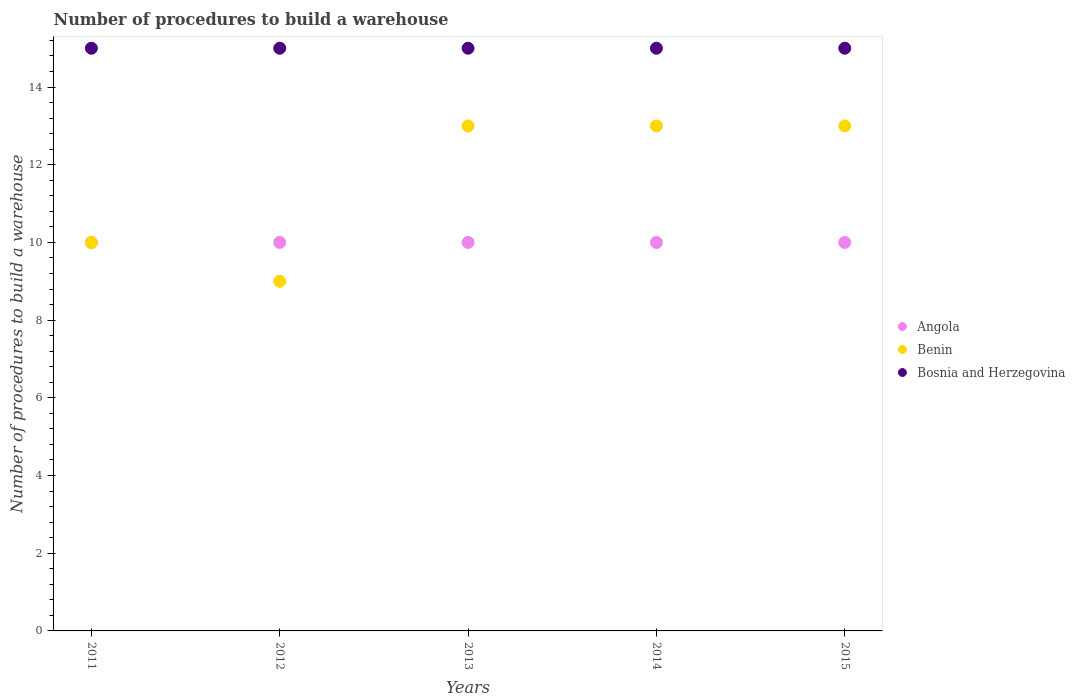How many different coloured dotlines are there?
Offer a very short reply. 3. Is the number of dotlines equal to the number of legend labels?
Provide a short and direct response. Yes. What is the number of procedures to build a warehouse in in Benin in 2011?
Your answer should be compact. 10. Across all years, what is the maximum number of procedures to build a warehouse in in Bosnia and Herzegovina?
Offer a very short reply. 15. Across all years, what is the minimum number of procedures to build a warehouse in in Angola?
Keep it short and to the point. 10. In which year was the number of procedures to build a warehouse in in Benin maximum?
Ensure brevity in your answer.  2013. In which year was the number of procedures to build a warehouse in in Bosnia and Herzegovina minimum?
Offer a very short reply. 2011. What is the total number of procedures to build a warehouse in in Angola in the graph?
Provide a short and direct response. 50. What is the difference between the number of procedures to build a warehouse in in Bosnia and Herzegovina in 2011 and that in 2013?
Your answer should be very brief. 0. What is the difference between the number of procedures to build a warehouse in in Bosnia and Herzegovina in 2013 and the number of procedures to build a warehouse in in Angola in 2014?
Make the answer very short. 5. What is the average number of procedures to build a warehouse in in Angola per year?
Offer a very short reply. 10. In the year 2012, what is the difference between the number of procedures to build a warehouse in in Angola and number of procedures to build a warehouse in in Benin?
Offer a terse response. 1. In how many years, is the number of procedures to build a warehouse in in Bosnia and Herzegovina greater than 12.8?
Keep it short and to the point. 5. What is the difference between the highest and the second highest number of procedures to build a warehouse in in Bosnia and Herzegovina?
Provide a succinct answer. 0. Is it the case that in every year, the sum of the number of procedures to build a warehouse in in Bosnia and Herzegovina and number of procedures to build a warehouse in in Benin  is greater than the number of procedures to build a warehouse in in Angola?
Your answer should be very brief. Yes. Is the number of procedures to build a warehouse in in Angola strictly greater than the number of procedures to build a warehouse in in Benin over the years?
Ensure brevity in your answer.  No. Is the number of procedures to build a warehouse in in Benin strictly less than the number of procedures to build a warehouse in in Bosnia and Herzegovina over the years?
Give a very brief answer. Yes. How many dotlines are there?
Provide a short and direct response. 3. How many years are there in the graph?
Offer a terse response. 5. Are the values on the major ticks of Y-axis written in scientific E-notation?
Give a very brief answer. No. How are the legend labels stacked?
Your response must be concise. Vertical. What is the title of the graph?
Your answer should be compact. Number of procedures to build a warehouse. What is the label or title of the Y-axis?
Provide a short and direct response. Number of procedures to build a warehouse. What is the Number of procedures to build a warehouse of Benin in 2011?
Offer a very short reply. 10. What is the Number of procedures to build a warehouse in Angola in 2013?
Offer a terse response. 10. What is the Number of procedures to build a warehouse of Benin in 2013?
Your response must be concise. 13. What is the Number of procedures to build a warehouse in Angola in 2014?
Your answer should be very brief. 10. What is the Number of procedures to build a warehouse in Bosnia and Herzegovina in 2014?
Provide a succinct answer. 15. What is the Number of procedures to build a warehouse in Benin in 2015?
Your response must be concise. 13. What is the Number of procedures to build a warehouse in Bosnia and Herzegovina in 2015?
Your answer should be compact. 15. Across all years, what is the maximum Number of procedures to build a warehouse in Angola?
Your answer should be compact. 10. What is the total Number of procedures to build a warehouse in Angola in the graph?
Your answer should be very brief. 50. What is the total Number of procedures to build a warehouse in Benin in the graph?
Provide a succinct answer. 58. What is the total Number of procedures to build a warehouse of Bosnia and Herzegovina in the graph?
Keep it short and to the point. 75. What is the difference between the Number of procedures to build a warehouse of Angola in 2011 and that in 2013?
Provide a short and direct response. 0. What is the difference between the Number of procedures to build a warehouse in Benin in 2011 and that in 2013?
Ensure brevity in your answer.  -3. What is the difference between the Number of procedures to build a warehouse of Bosnia and Herzegovina in 2011 and that in 2013?
Provide a short and direct response. 0. What is the difference between the Number of procedures to build a warehouse of Angola in 2011 and that in 2014?
Offer a terse response. 0. What is the difference between the Number of procedures to build a warehouse of Benin in 2011 and that in 2014?
Give a very brief answer. -3. What is the difference between the Number of procedures to build a warehouse in Bosnia and Herzegovina in 2011 and that in 2014?
Keep it short and to the point. 0. What is the difference between the Number of procedures to build a warehouse in Angola in 2011 and that in 2015?
Provide a short and direct response. 0. What is the difference between the Number of procedures to build a warehouse in Angola in 2012 and that in 2014?
Provide a succinct answer. 0. What is the difference between the Number of procedures to build a warehouse in Benin in 2012 and that in 2014?
Provide a succinct answer. -4. What is the difference between the Number of procedures to build a warehouse of Bosnia and Herzegovina in 2012 and that in 2015?
Ensure brevity in your answer.  0. What is the difference between the Number of procedures to build a warehouse in Bosnia and Herzegovina in 2013 and that in 2014?
Make the answer very short. 0. What is the difference between the Number of procedures to build a warehouse of Angola in 2013 and that in 2015?
Make the answer very short. 0. What is the difference between the Number of procedures to build a warehouse of Bosnia and Herzegovina in 2013 and that in 2015?
Give a very brief answer. 0. What is the difference between the Number of procedures to build a warehouse of Angola in 2014 and that in 2015?
Provide a short and direct response. 0. What is the difference between the Number of procedures to build a warehouse in Benin in 2014 and that in 2015?
Your response must be concise. 0. What is the difference between the Number of procedures to build a warehouse in Angola in 2011 and the Number of procedures to build a warehouse in Benin in 2012?
Your response must be concise. 1. What is the difference between the Number of procedures to build a warehouse of Angola in 2011 and the Number of procedures to build a warehouse of Benin in 2014?
Your response must be concise. -3. What is the difference between the Number of procedures to build a warehouse in Angola in 2011 and the Number of procedures to build a warehouse in Bosnia and Herzegovina in 2014?
Your answer should be very brief. -5. What is the difference between the Number of procedures to build a warehouse in Benin in 2011 and the Number of procedures to build a warehouse in Bosnia and Herzegovina in 2014?
Your response must be concise. -5. What is the difference between the Number of procedures to build a warehouse in Benin in 2011 and the Number of procedures to build a warehouse in Bosnia and Herzegovina in 2015?
Keep it short and to the point. -5. What is the difference between the Number of procedures to build a warehouse in Benin in 2012 and the Number of procedures to build a warehouse in Bosnia and Herzegovina in 2013?
Provide a succinct answer. -6. What is the difference between the Number of procedures to build a warehouse of Angola in 2012 and the Number of procedures to build a warehouse of Benin in 2014?
Give a very brief answer. -3. What is the difference between the Number of procedures to build a warehouse in Angola in 2012 and the Number of procedures to build a warehouse in Benin in 2015?
Give a very brief answer. -3. What is the difference between the Number of procedures to build a warehouse in Benin in 2012 and the Number of procedures to build a warehouse in Bosnia and Herzegovina in 2015?
Make the answer very short. -6. What is the difference between the Number of procedures to build a warehouse in Angola in 2013 and the Number of procedures to build a warehouse in Benin in 2014?
Provide a succinct answer. -3. What is the difference between the Number of procedures to build a warehouse of Angola in 2013 and the Number of procedures to build a warehouse of Bosnia and Herzegovina in 2014?
Offer a very short reply. -5. What is the difference between the Number of procedures to build a warehouse of Angola in 2013 and the Number of procedures to build a warehouse of Benin in 2015?
Provide a short and direct response. -3. What is the difference between the Number of procedures to build a warehouse of Angola in 2013 and the Number of procedures to build a warehouse of Bosnia and Herzegovina in 2015?
Offer a terse response. -5. What is the difference between the Number of procedures to build a warehouse of Benin in 2013 and the Number of procedures to build a warehouse of Bosnia and Herzegovina in 2015?
Make the answer very short. -2. What is the difference between the Number of procedures to build a warehouse of Angola in 2014 and the Number of procedures to build a warehouse of Benin in 2015?
Your response must be concise. -3. What is the difference between the Number of procedures to build a warehouse in Angola in 2014 and the Number of procedures to build a warehouse in Bosnia and Herzegovina in 2015?
Your response must be concise. -5. What is the difference between the Number of procedures to build a warehouse of Benin in 2014 and the Number of procedures to build a warehouse of Bosnia and Herzegovina in 2015?
Give a very brief answer. -2. What is the average Number of procedures to build a warehouse of Angola per year?
Ensure brevity in your answer.  10. What is the average Number of procedures to build a warehouse in Bosnia and Herzegovina per year?
Give a very brief answer. 15. In the year 2012, what is the difference between the Number of procedures to build a warehouse of Angola and Number of procedures to build a warehouse of Benin?
Offer a terse response. 1. In the year 2012, what is the difference between the Number of procedures to build a warehouse of Benin and Number of procedures to build a warehouse of Bosnia and Herzegovina?
Give a very brief answer. -6. In the year 2013, what is the difference between the Number of procedures to build a warehouse of Angola and Number of procedures to build a warehouse of Benin?
Offer a terse response. -3. In the year 2013, what is the difference between the Number of procedures to build a warehouse of Angola and Number of procedures to build a warehouse of Bosnia and Herzegovina?
Your answer should be very brief. -5. In the year 2014, what is the difference between the Number of procedures to build a warehouse of Angola and Number of procedures to build a warehouse of Bosnia and Herzegovina?
Your answer should be compact. -5. What is the ratio of the Number of procedures to build a warehouse of Benin in 2011 to that in 2012?
Your answer should be compact. 1.11. What is the ratio of the Number of procedures to build a warehouse in Angola in 2011 to that in 2013?
Keep it short and to the point. 1. What is the ratio of the Number of procedures to build a warehouse of Benin in 2011 to that in 2013?
Make the answer very short. 0.77. What is the ratio of the Number of procedures to build a warehouse in Benin in 2011 to that in 2014?
Give a very brief answer. 0.77. What is the ratio of the Number of procedures to build a warehouse in Angola in 2011 to that in 2015?
Keep it short and to the point. 1. What is the ratio of the Number of procedures to build a warehouse of Benin in 2011 to that in 2015?
Keep it short and to the point. 0.77. What is the ratio of the Number of procedures to build a warehouse of Bosnia and Herzegovina in 2011 to that in 2015?
Offer a terse response. 1. What is the ratio of the Number of procedures to build a warehouse in Angola in 2012 to that in 2013?
Provide a short and direct response. 1. What is the ratio of the Number of procedures to build a warehouse in Benin in 2012 to that in 2013?
Ensure brevity in your answer.  0.69. What is the ratio of the Number of procedures to build a warehouse of Benin in 2012 to that in 2014?
Make the answer very short. 0.69. What is the ratio of the Number of procedures to build a warehouse of Bosnia and Herzegovina in 2012 to that in 2014?
Provide a short and direct response. 1. What is the ratio of the Number of procedures to build a warehouse of Benin in 2012 to that in 2015?
Provide a short and direct response. 0.69. What is the ratio of the Number of procedures to build a warehouse in Angola in 2013 to that in 2014?
Provide a succinct answer. 1. What is the ratio of the Number of procedures to build a warehouse in Benin in 2013 to that in 2014?
Provide a short and direct response. 1. What is the ratio of the Number of procedures to build a warehouse in Benin in 2013 to that in 2015?
Provide a succinct answer. 1. What is the ratio of the Number of procedures to build a warehouse of Bosnia and Herzegovina in 2013 to that in 2015?
Offer a terse response. 1. What is the ratio of the Number of procedures to build a warehouse of Angola in 2014 to that in 2015?
Keep it short and to the point. 1. What is the ratio of the Number of procedures to build a warehouse of Benin in 2014 to that in 2015?
Give a very brief answer. 1. What is the difference between the highest and the second highest Number of procedures to build a warehouse in Angola?
Provide a short and direct response. 0. What is the difference between the highest and the second highest Number of procedures to build a warehouse in Benin?
Your response must be concise. 0. What is the difference between the highest and the lowest Number of procedures to build a warehouse in Angola?
Your answer should be compact. 0. What is the difference between the highest and the lowest Number of procedures to build a warehouse in Bosnia and Herzegovina?
Give a very brief answer. 0. 